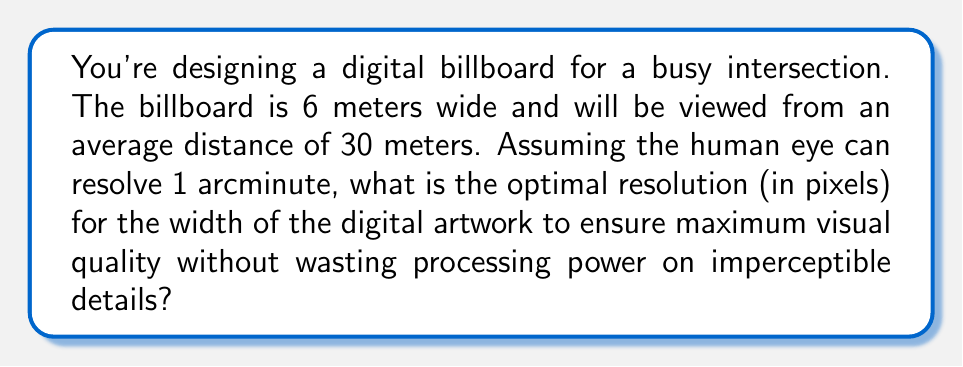Show me your answer to this math problem. To solve this problem, we'll follow these steps:

1) Convert 1 arcminute to radians:
   $$ 1 \text{ arcminute} = \frac{1}{60} \text{ degree} = \frac{\pi}{60 \times 180} \text{ radians} $$

2) Calculate the smallest detail the human eye can resolve at the viewing distance:
   $$ \text{Detail size} = 30 \text{ m} \times \tan(\frac{\pi}{60 \times 180}) \approx 0.00873 \text{ m} $$

3) Calculate how many of these details fit across the width of the billboard:
   $$ \text{Number of details} = \frac{6 \text{ m}}{0.00873 \text{ m}} \approx 687.3 $$

4) Round up to the nearest whole number, as we can't have a fractional pixel:
   $$ \text{Optimal resolution} = \lceil 687.3 \rceil = 688 \text{ pixels} $$

This resolution ensures that each pixel is just at the limit of what the human eye can resolve from the given viewing distance, providing maximum perceived quality without wasting processing power on imperceptible details.
Answer: 688 pixels 